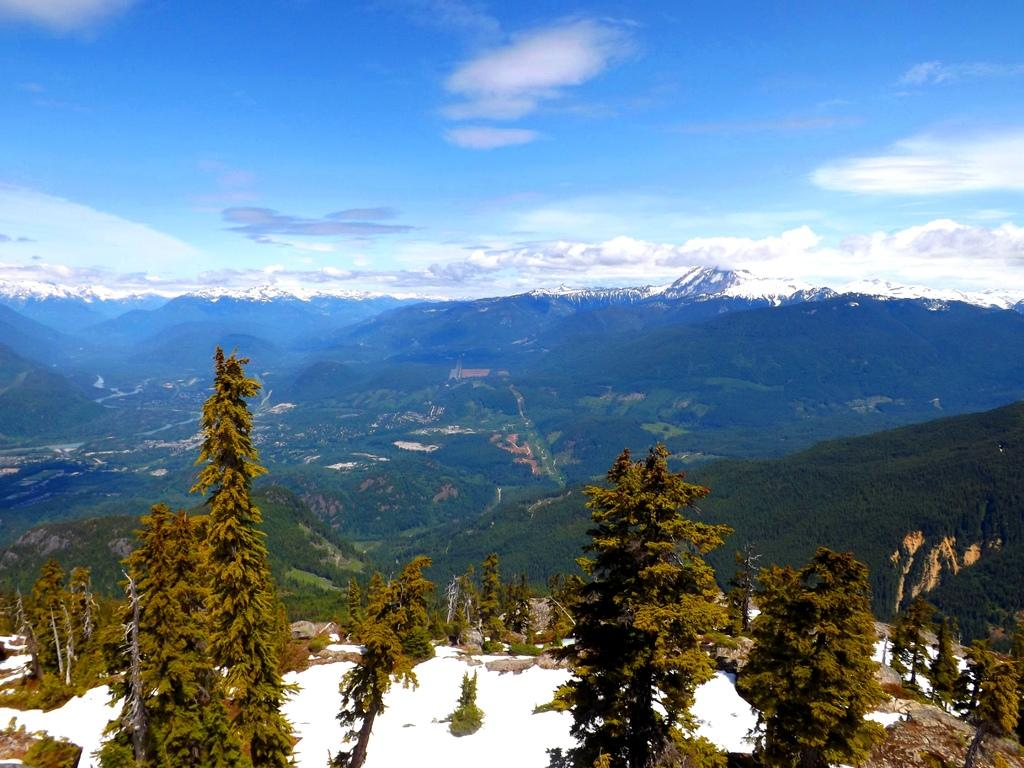What is present at the bottom of the image? There is snow and trees at the bottom of the image. What can be seen in the background of the image? There are mountains and trees in the background of the image. What is visible at the top of the image? The sky is visible at the top of the image. What type of poison is present in the image? There is no poison present in the image. Can you describe the condition of the trees in the image? The provided facts do not mention the condition of the trees, so we cannot describe it. 